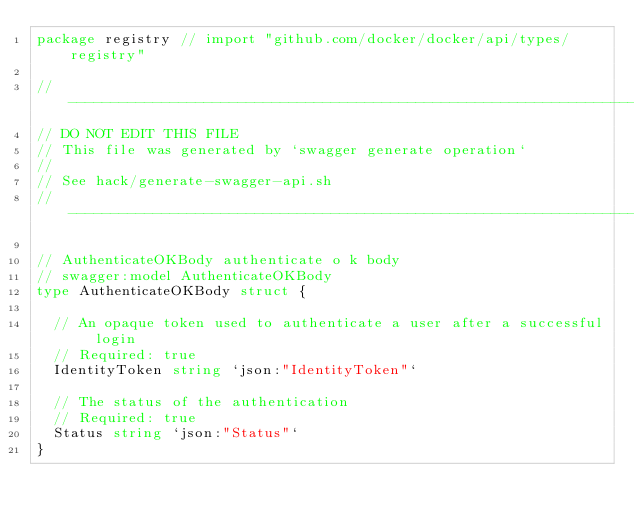Convert code to text. <code><loc_0><loc_0><loc_500><loc_500><_Go_>package registry // import "github.com/docker/docker/api/types/registry"

// ----------------------------------------------------------------------------
// DO NOT EDIT THIS FILE
// This file was generated by `swagger generate operation`
//
// See hack/generate-swagger-api.sh
// ----------------------------------------------------------------------------

// AuthenticateOKBody authenticate o k body
// swagger:model AuthenticateOKBody
type AuthenticateOKBody struct {

	// An opaque token used to authenticate a user after a successful login
	// Required: true
	IdentityToken string `json:"IdentityToken"`

	// The status of the authentication
	// Required: true
	Status string `json:"Status"`
}
</code> 